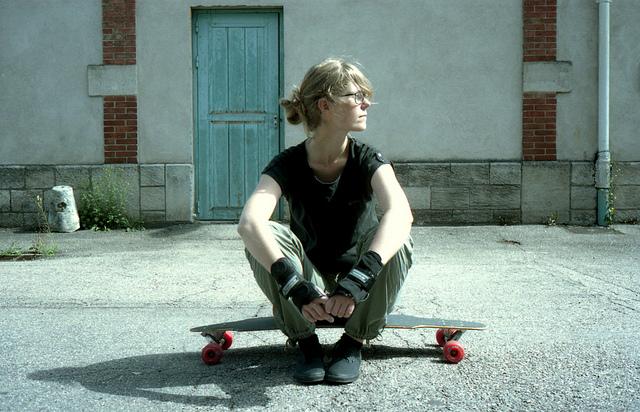Is this woman looking towards the sun?
Write a very short answer. Yes. Is she riding the board?
Be succinct. No. What is on her hands?
Answer briefly. Wrist guards. 